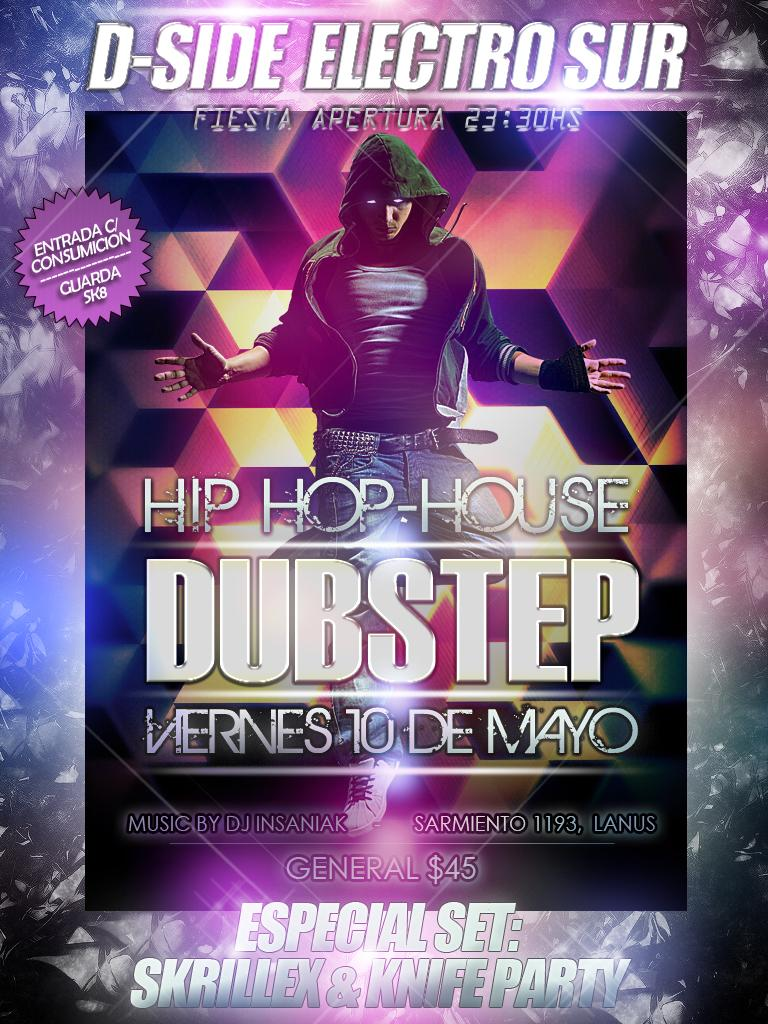<image>
Create a compact narrative representing the image presented. The show being advertised on the poster is call Hip Hop-House and admission cost $45.00 